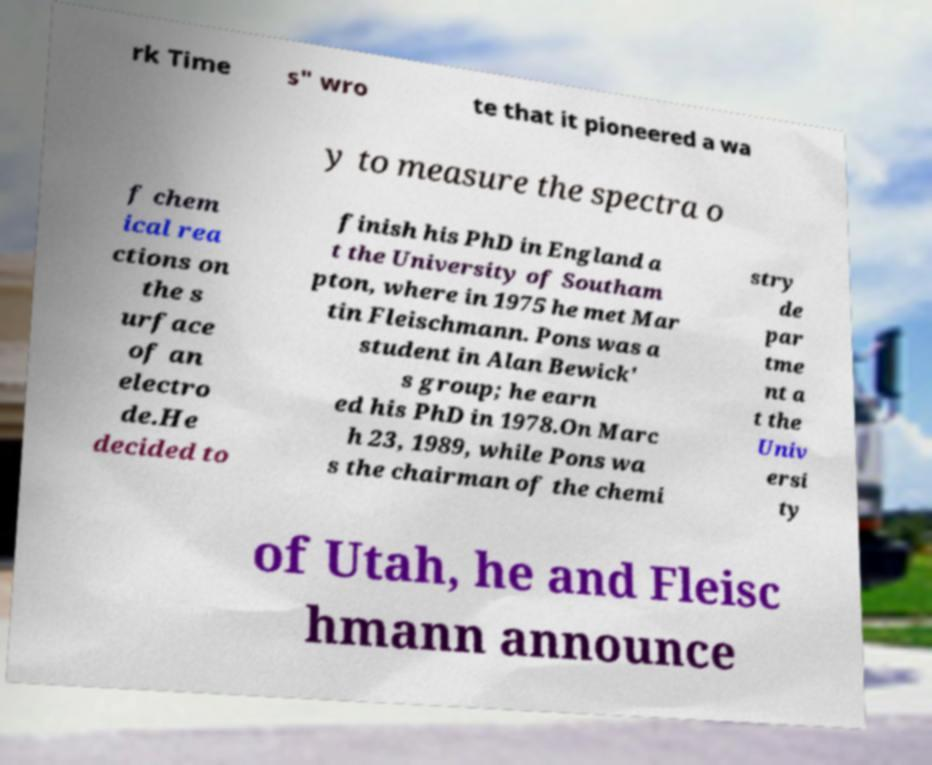Please read and relay the text visible in this image. What does it say? rk Time s" wro te that it pioneered a wa y to measure the spectra o f chem ical rea ctions on the s urface of an electro de.He decided to finish his PhD in England a t the University of Southam pton, where in 1975 he met Mar tin Fleischmann. Pons was a student in Alan Bewick' s group; he earn ed his PhD in 1978.On Marc h 23, 1989, while Pons wa s the chairman of the chemi stry de par tme nt a t the Univ ersi ty of Utah, he and Fleisc hmann announce 